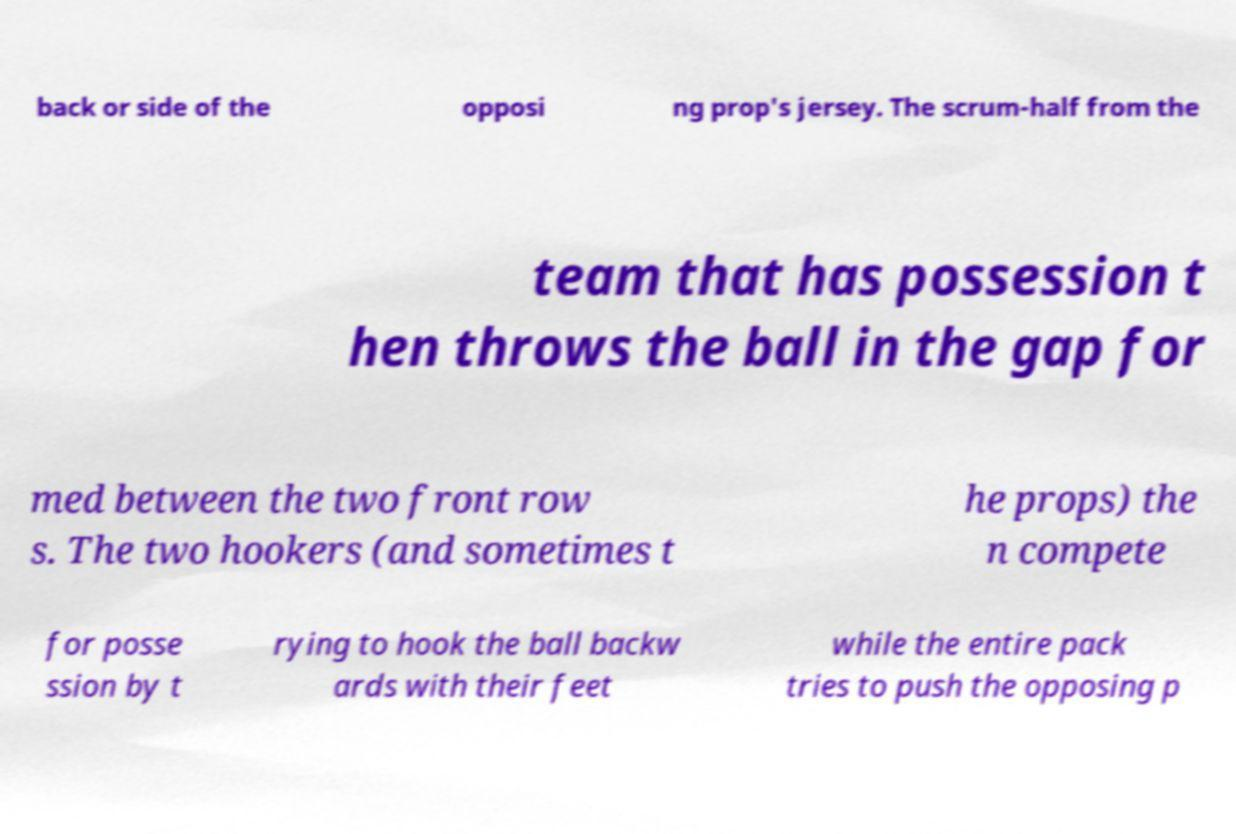Could you extract and type out the text from this image? back or side of the opposi ng prop's jersey. The scrum-half from the team that has possession t hen throws the ball in the gap for med between the two front row s. The two hookers (and sometimes t he props) the n compete for posse ssion by t rying to hook the ball backw ards with their feet while the entire pack tries to push the opposing p 